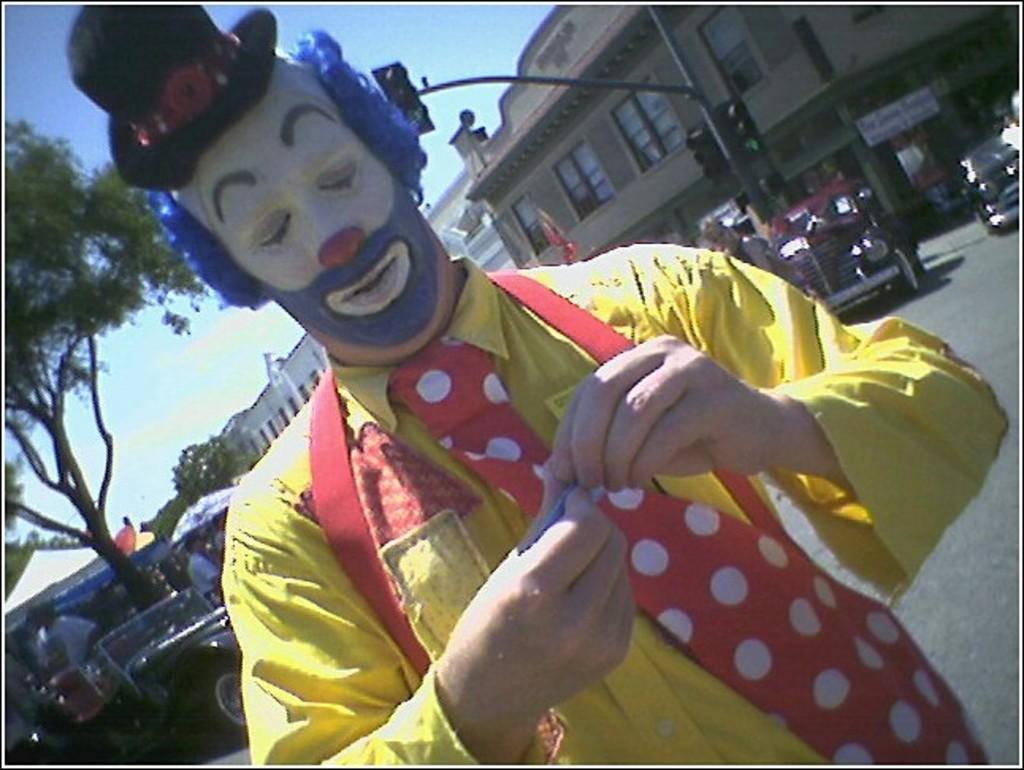Describe this image in one or two sentences. In this picture I can observe a person in the middle of the picture. There is paint on his face. He is wearing yellow color shirt and black color hat on his head. In the background I can observe buildings, trees and sky. 